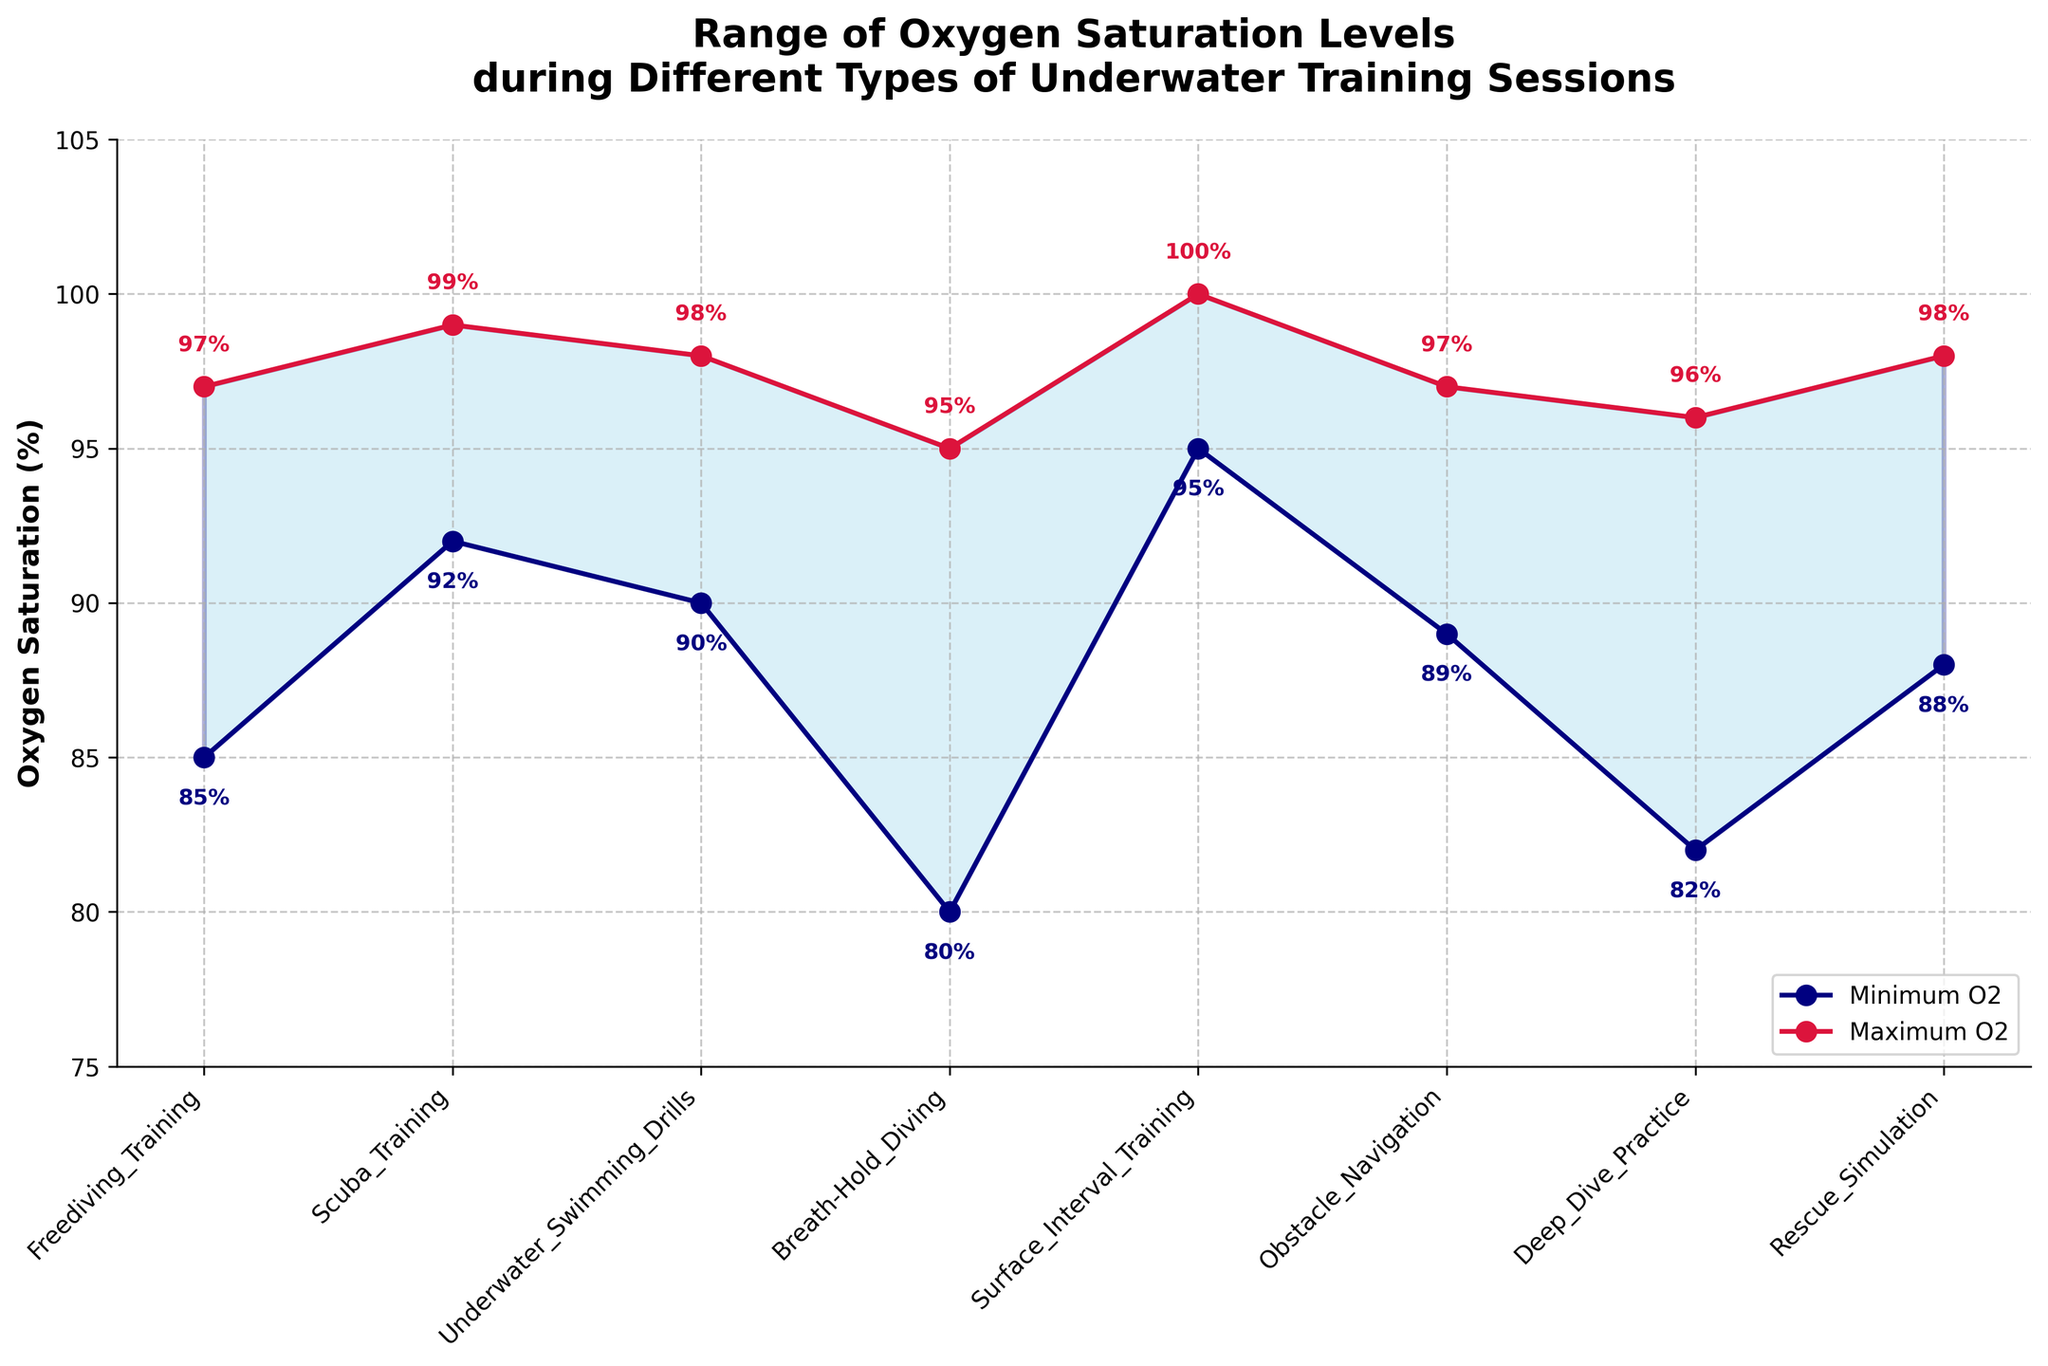What's the minimum oxygen saturation level recorded during Breath-Hold Diving? Find the Breath-Hold Diving session in the figure, and locate the minimum value reported for oxygen saturation.
Answer: 80% What's the range of oxygen saturation levels during Deep Dive Practice? Locate Deep Dive Practice on the x-axis, then find the minimum and maximum values. Subtract the minimum from the maximum.
Answer: 14% Which session has the highest maximum oxygen saturation level? Look across all sessions for the highest maximum oxygen level.
Answer: Surface Interval Training What's the average maximum oxygen saturation level across all sessions? Add the maximum oxygen saturation levels for all sessions, then divide by the number of sessions. (97+99+98+95+100+97+96+98) / 8
Answer: 97.5% Which session shows the greatest difference between minimum and maximum oxygen saturation levels? Calculate the difference between maximum and minimum values for each session and compare them. The session with the highest difference is the answer.
Answer: Breath-Hold Diving How many sessions recorded a minimum oxygen saturation level below 90%? Count the sessions where the minimum oxygen level is below 90%.
Answer: 4 For Scuba Training, how much higher is the maximum oxygen saturation level compared to the minimum? Find the difference between the maximum and minimum saturation levels for Scuba Training.
Answer: 7% Are there any sessions where the minimum and maximum oxygen saturation levels are equal? Check if for any session the minimum and maximum values are the same.
Answer: No What is the title of the chart? Read the title from the top of the chart.
Answer: Range of Oxygen Saturation Levels during Different Types of Underwater Training Sessions Which session has a minimum oxygen saturation level closest to 85%? Locate the session with a minimum oxygen saturation value nearest to 85%.
Answer: Freediving Training 